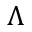Convert formula to latex. <formula><loc_0><loc_0><loc_500><loc_500>\Lambda</formula> 